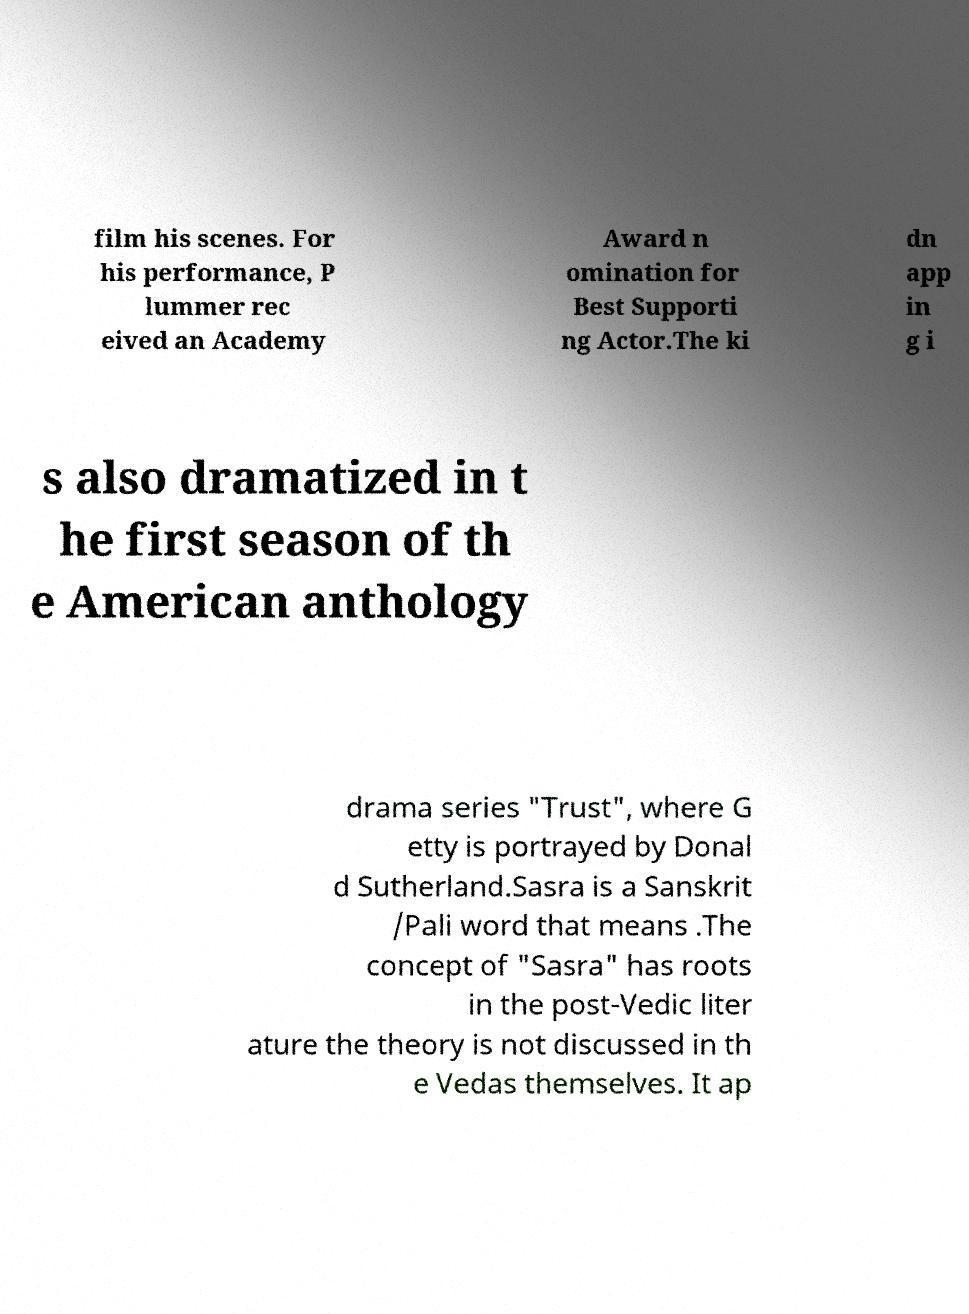Could you assist in decoding the text presented in this image and type it out clearly? film his scenes. For his performance, P lummer rec eived an Academy Award n omination for Best Supporti ng Actor.The ki dn app in g i s also dramatized in t he first season of th e American anthology drama series "Trust", where G etty is portrayed by Donal d Sutherland.Sasra is a Sanskrit /Pali word that means .The concept of "Sasra" has roots in the post-Vedic liter ature the theory is not discussed in th e Vedas themselves. It ap 